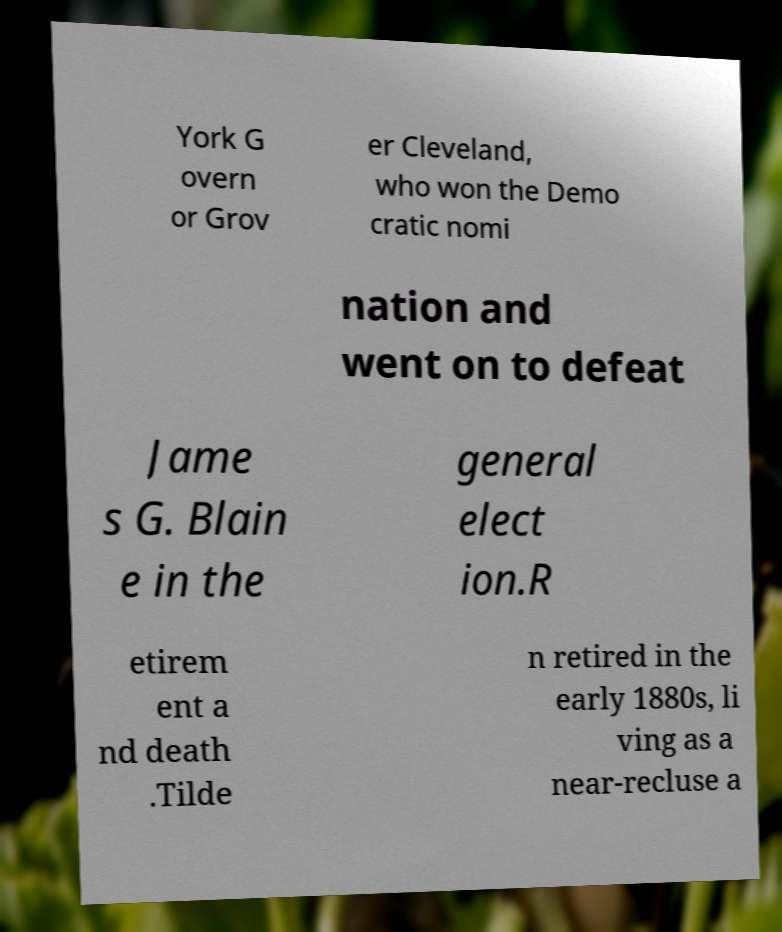Could you extract and type out the text from this image? York G overn or Grov er Cleveland, who won the Demo cratic nomi nation and went on to defeat Jame s G. Blain e in the general elect ion.R etirem ent a nd death .Tilde n retired in the early 1880s, li ving as a near-recluse a 